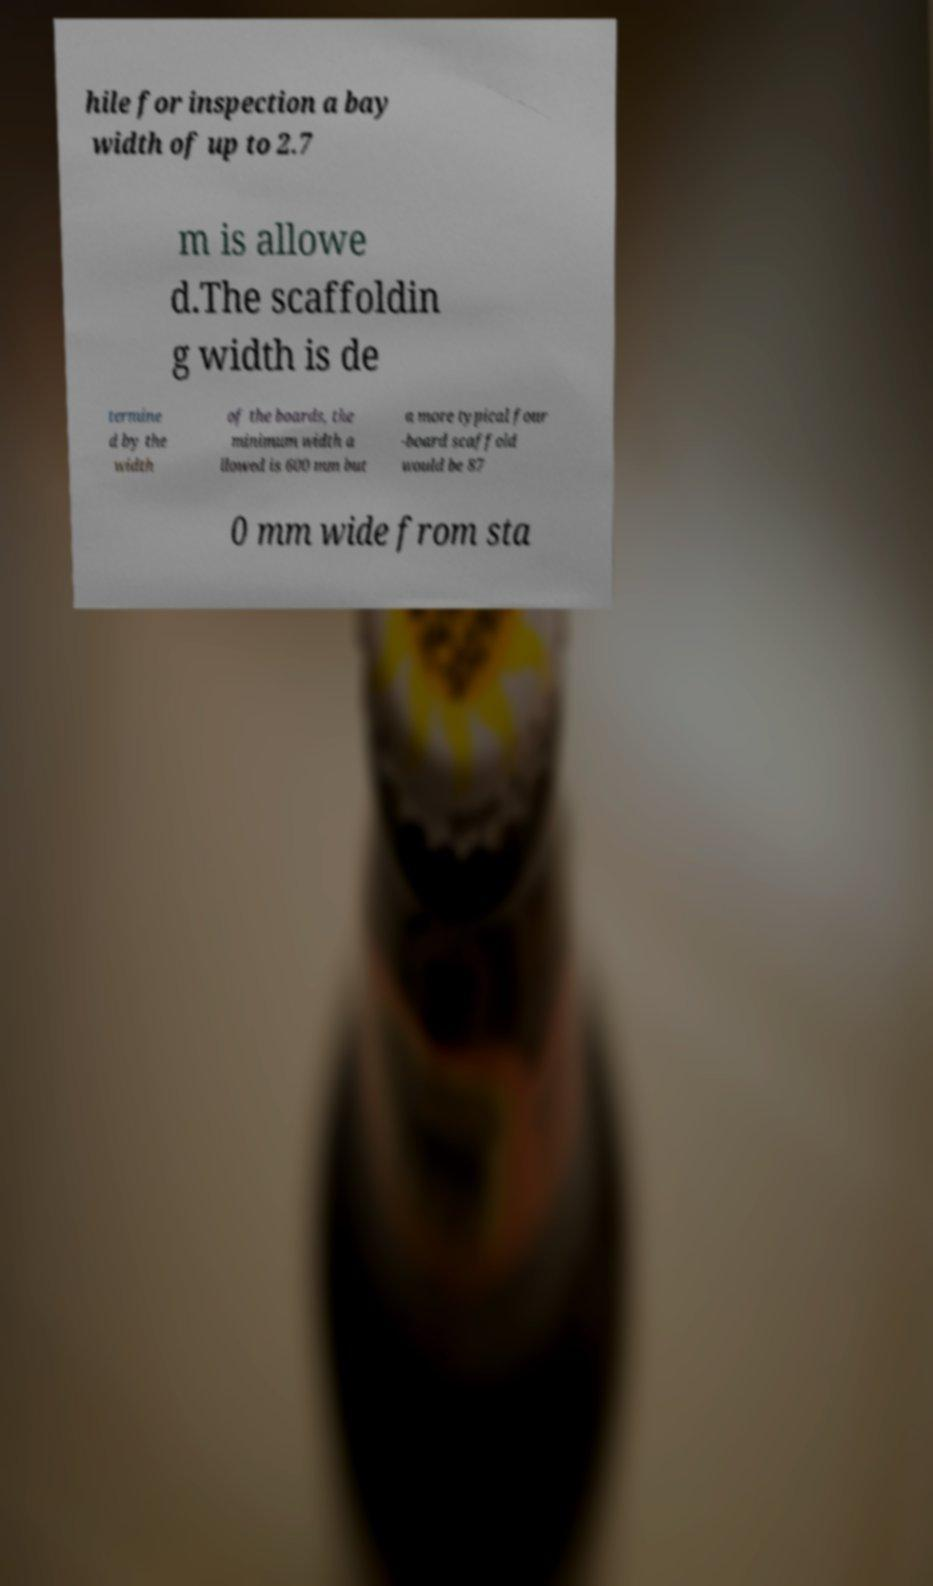Can you read and provide the text displayed in the image?This photo seems to have some interesting text. Can you extract and type it out for me? hile for inspection a bay width of up to 2.7 m is allowe d.The scaffoldin g width is de termine d by the width of the boards, the minimum width a llowed is 600 mm but a more typical four -board scaffold would be 87 0 mm wide from sta 